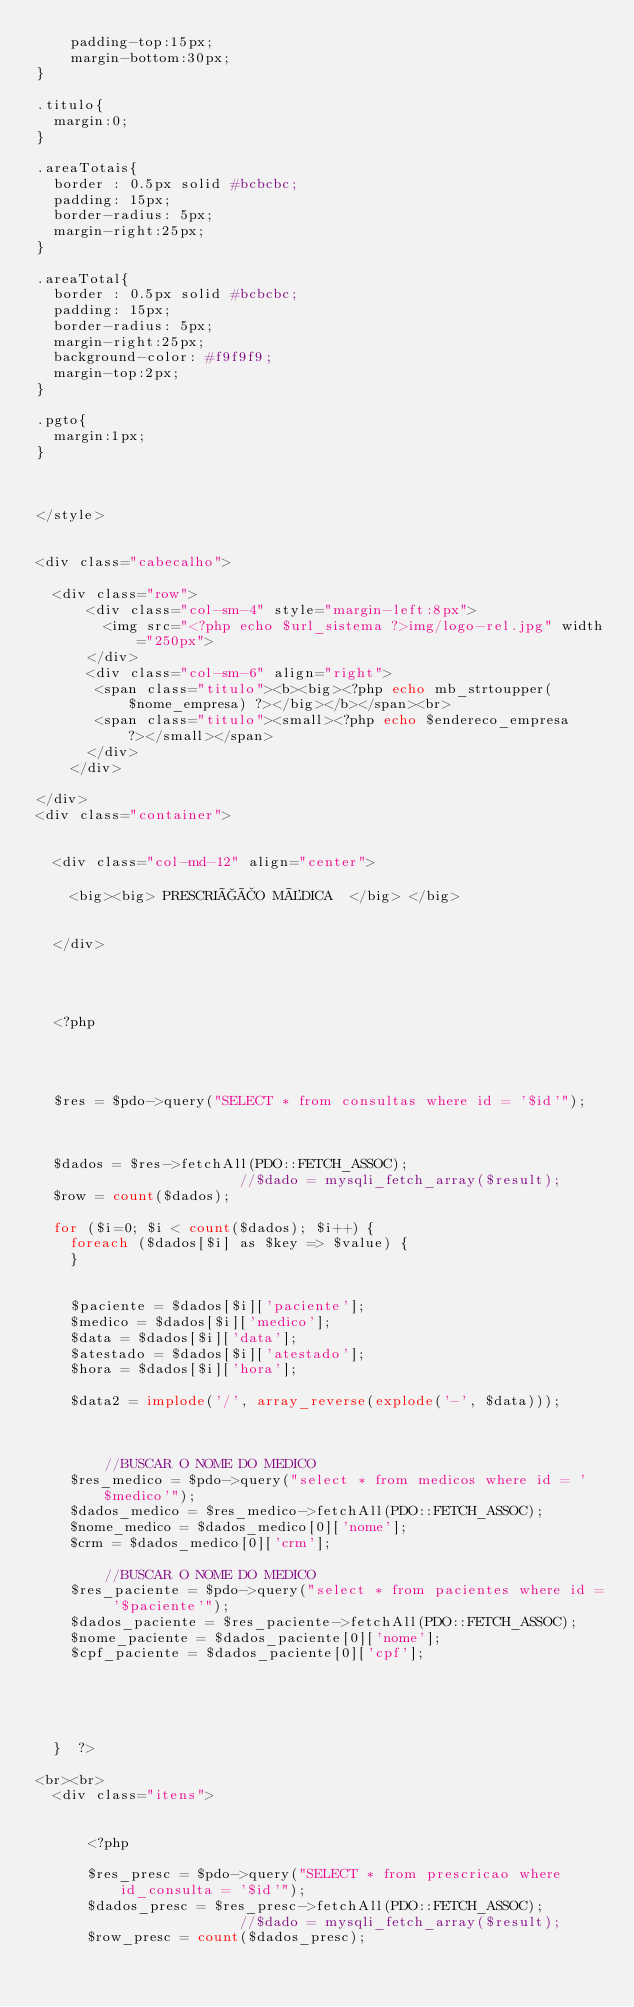<code> <loc_0><loc_0><loc_500><loc_500><_PHP_>    padding-top:15px;
    margin-bottom:30px;
}

.titulo{
	margin:0;
}

.areaTotais{
	border : 0.5px solid #bcbcbc;
	padding: 15px;
	border-radius: 5px;
	margin-right:25px;
}

.areaTotal{
	border : 0.5px solid #bcbcbc;
	padding: 15px;
	border-radius: 5px;
	margin-right:25px;
	background-color: #f9f9f9;
	margin-top:2px;
}

.pgto{
	margin:1px;
}



</style>


<div class="cabecalho">
	
	<div class="row">
			<div class="col-sm-4" style="margin-left:8px">	
			  <img src="<?php echo $url_sistema ?>img/logo-rel.jpg" width="250px">
			</div>
			<div class="col-sm-6" align="right">	
			 <span class="titulo"><b><big><?php echo mb_strtoupper($nome_empresa) ?></big></b></span><br>
			 <span class="titulo"><small><?php echo $endereco_empresa ?></small></span>
			</div>
		</div>

</div>
<div class="container">


	<div class="col-md-12" align="center">
		
		<big><big> PRESCRIÇÃO MÉDICA  </big> </big> 
		

	</div>

	
	

	<?php

	
	

	$res = $pdo->query("SELECT * from consultas where id = '$id'");
	


	$dados = $res->fetchAll(PDO::FETCH_ASSOC);
                        //$dado = mysqli_fetch_array($result);
	$row = count($dados);

	for ($i=0; $i < count($dados); $i++) { 
		foreach ($dados[$i] as $key => $value) {
		}


		$paciente = $dados[$i]['paciente'];
		$medico = $dados[$i]['medico'];
		$data = $dados[$i]['data'];
		$atestado = $dados[$i]['atestado'];
		$hora = $dados[$i]['hora'];

		$data2 = implode('/', array_reverse(explode('-', $data)));



				//BUSCAR O NOME DO MEDICO
		$res_medico = $pdo->query("select * from medicos where id = '$medico'");
		$dados_medico = $res_medico->fetchAll(PDO::FETCH_ASSOC);
		$nome_medico = $dados_medico[0]['nome'];
		$crm = $dados_medico[0]['crm'];

				//BUSCAR O NOME DO MEDICO
		$res_paciente = $pdo->query("select * from pacientes where id = '$paciente'");
		$dados_paciente = $res_paciente->fetchAll(PDO::FETCH_ASSOC);
		$nome_paciente = $dados_paciente[0]['nome'];
		$cpf_paciente = $dados_paciente[0]['cpf'];





	}  ?>

<br><br>
	<div class="itens">

			
			<?php 

			$res_presc = $pdo->query("SELECT * from prescricao where id_consulta = '$id'");
			$dados_presc = $res_presc->fetchAll(PDO::FETCH_ASSOC);
                        //$dado = mysqli_fetch_array($result);
			$row_presc = count($dados_presc);
</code> 